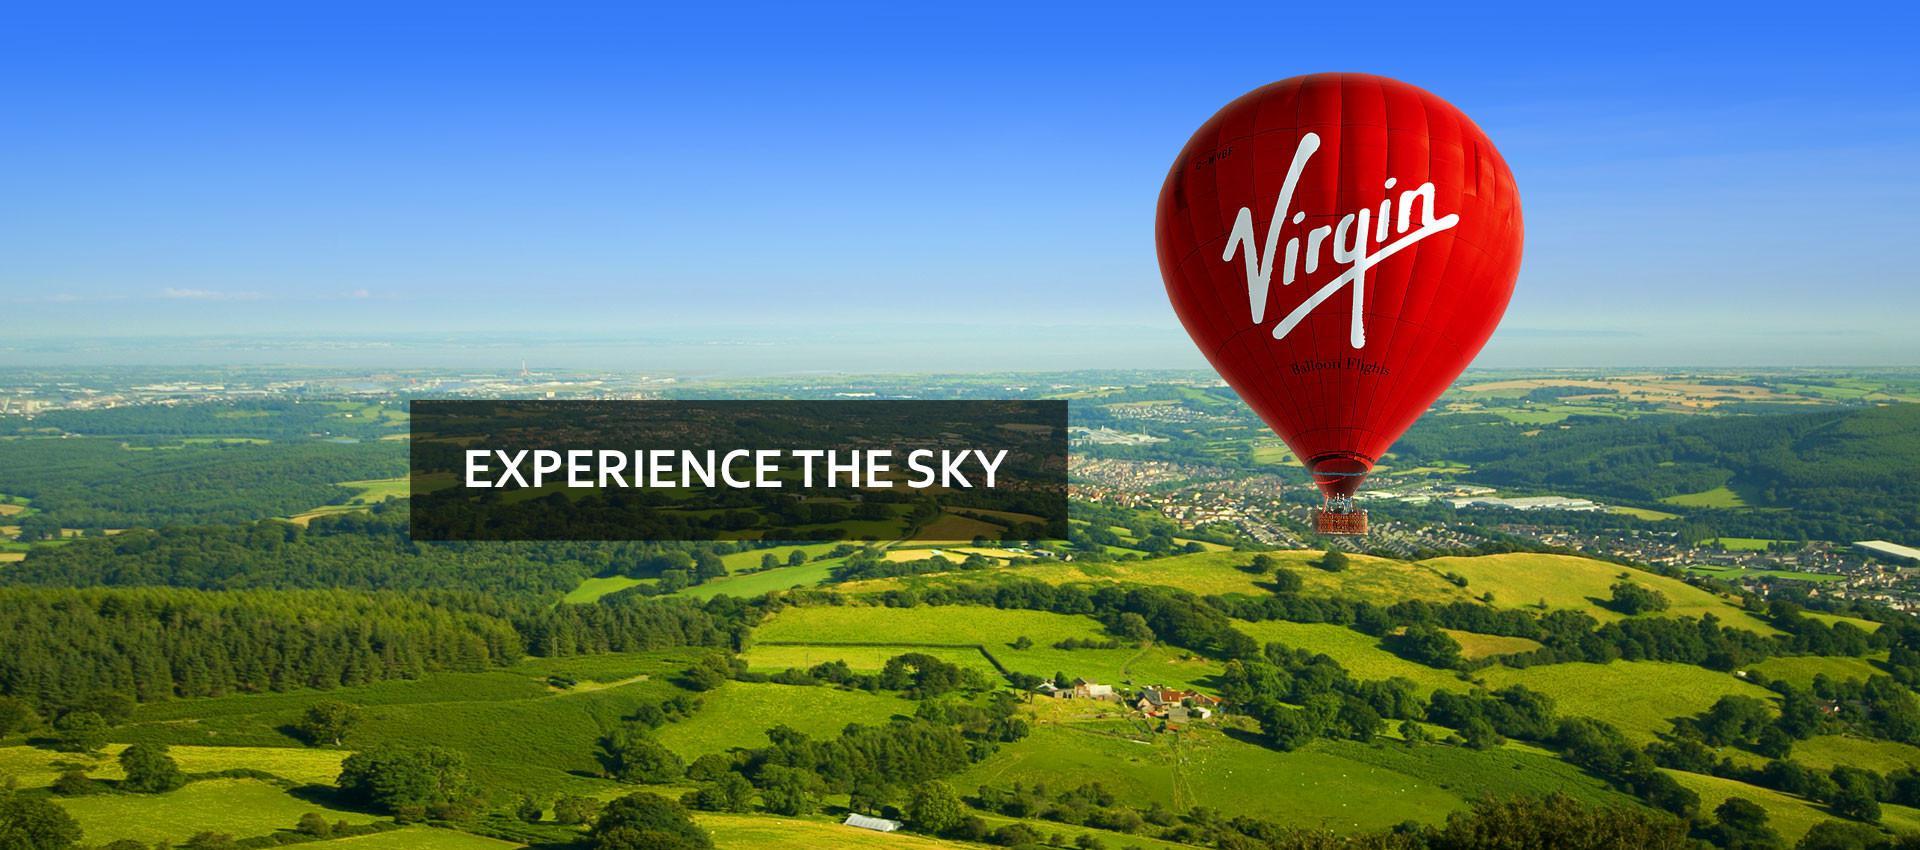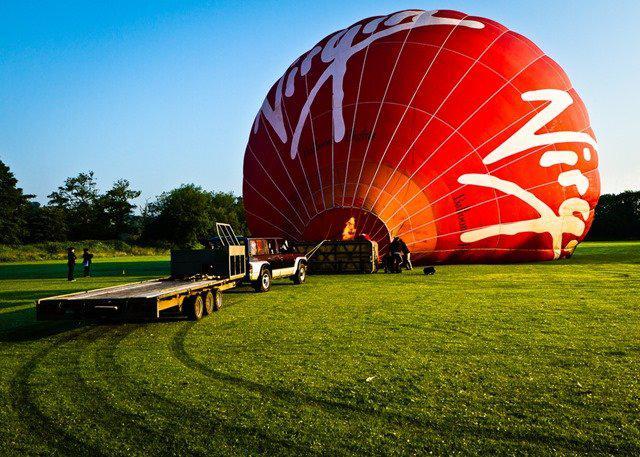The first image is the image on the left, the second image is the image on the right. For the images shown, is this caption "All hot air balloons have the same company logo." true? Answer yes or no. Yes. The first image is the image on the left, the second image is the image on the right. For the images displayed, is the sentence "There are only two balloons and they are both upright." factually correct? Answer yes or no. No. 